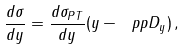Convert formula to latex. <formula><loc_0><loc_0><loc_500><loc_500>\frac { d \sigma } { d y } = \frac { d \sigma _ { P T } } { d y } ( y - \ p p D _ { y } ) \, ,</formula> 